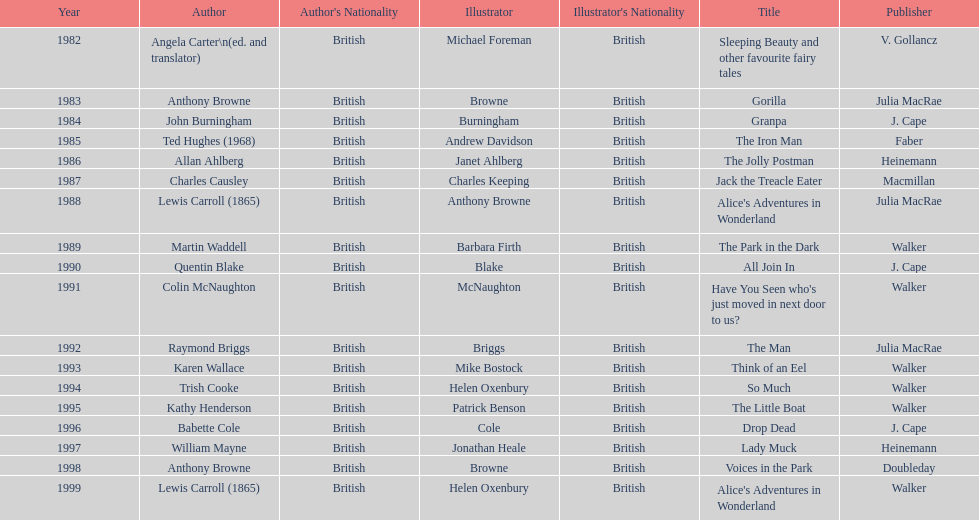Which other author, besides lewis carroll, has won the kurt maschler award twice? Anthony Browne. 